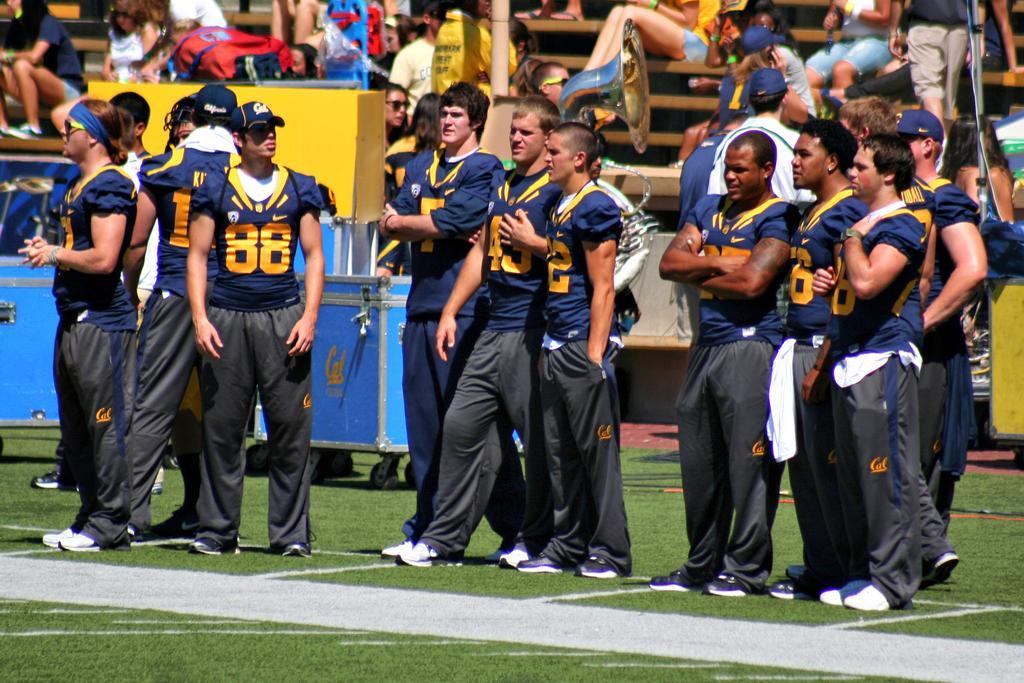In one or two sentences, can you explain what this image depicts? This image is taken outdoors. At the bottom of the image there is a ground with grass on it. In the middle of the image a few people are standing on the ground. In the background there is a wooden fence. There are many benches. Many people are sitting on the benches and a few are standing. 